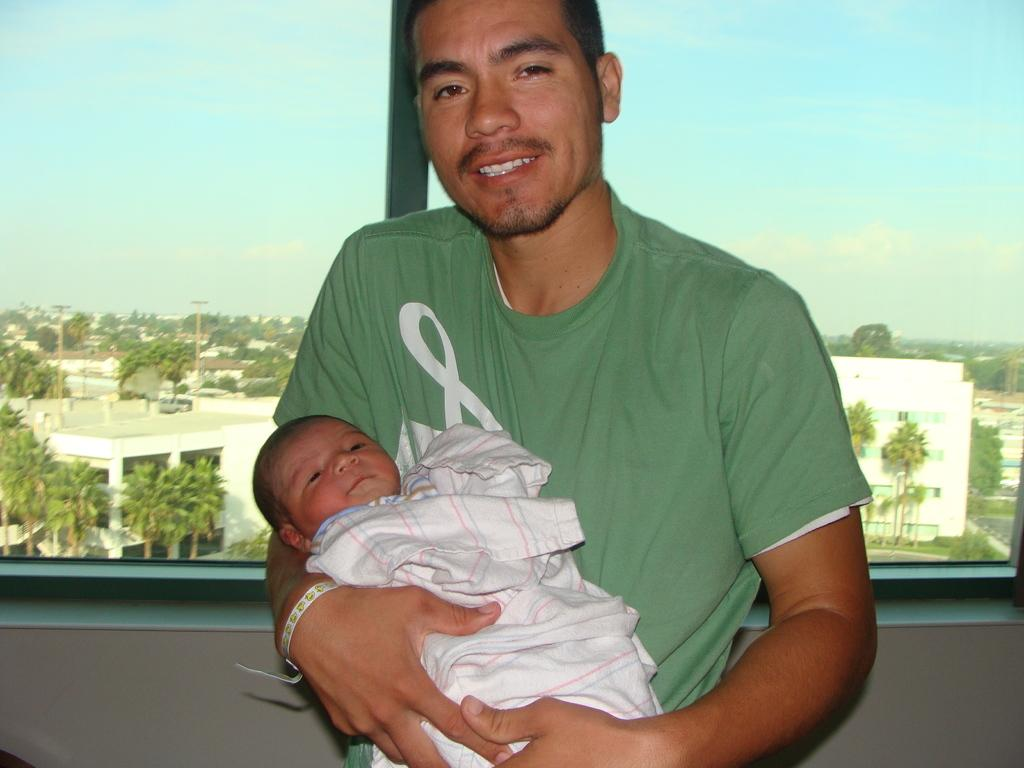What is the man in the image doing with the kid? The man is holding a kid in the image. What is the man's facial expression? The man is smiling in the image. What can be seen through the glass window in the image? Trees, buildings, poles, and the sky can be seen through the glass window in the image. What type of sand can be seen on the floor in the image? There is no sand present on the floor in the image. How does the man plan to expand his smile in the image? The image does not provide information about the man's plans to expand his smile. 